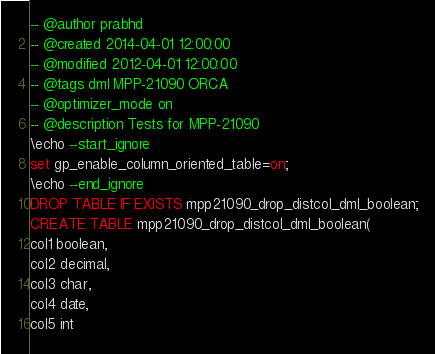Convert code to text. <code><loc_0><loc_0><loc_500><loc_500><_SQL_>-- @author prabhd 
-- @created 2014-04-01 12:00:00
-- @modified 2012-04-01 12:00:00
-- @tags dml MPP-21090 ORCA
-- @optimizer_mode on	
-- @description Tests for MPP-21090
\echo --start_ignore
set gp_enable_column_oriented_table=on;
\echo --end_ignore
DROP TABLE IF EXISTS mpp21090_drop_distcol_dml_boolean;
CREATE TABLE mpp21090_drop_distcol_dml_boolean(
col1 boolean,
col2 decimal,
col3 char,
col4 date,
col5 int</code> 